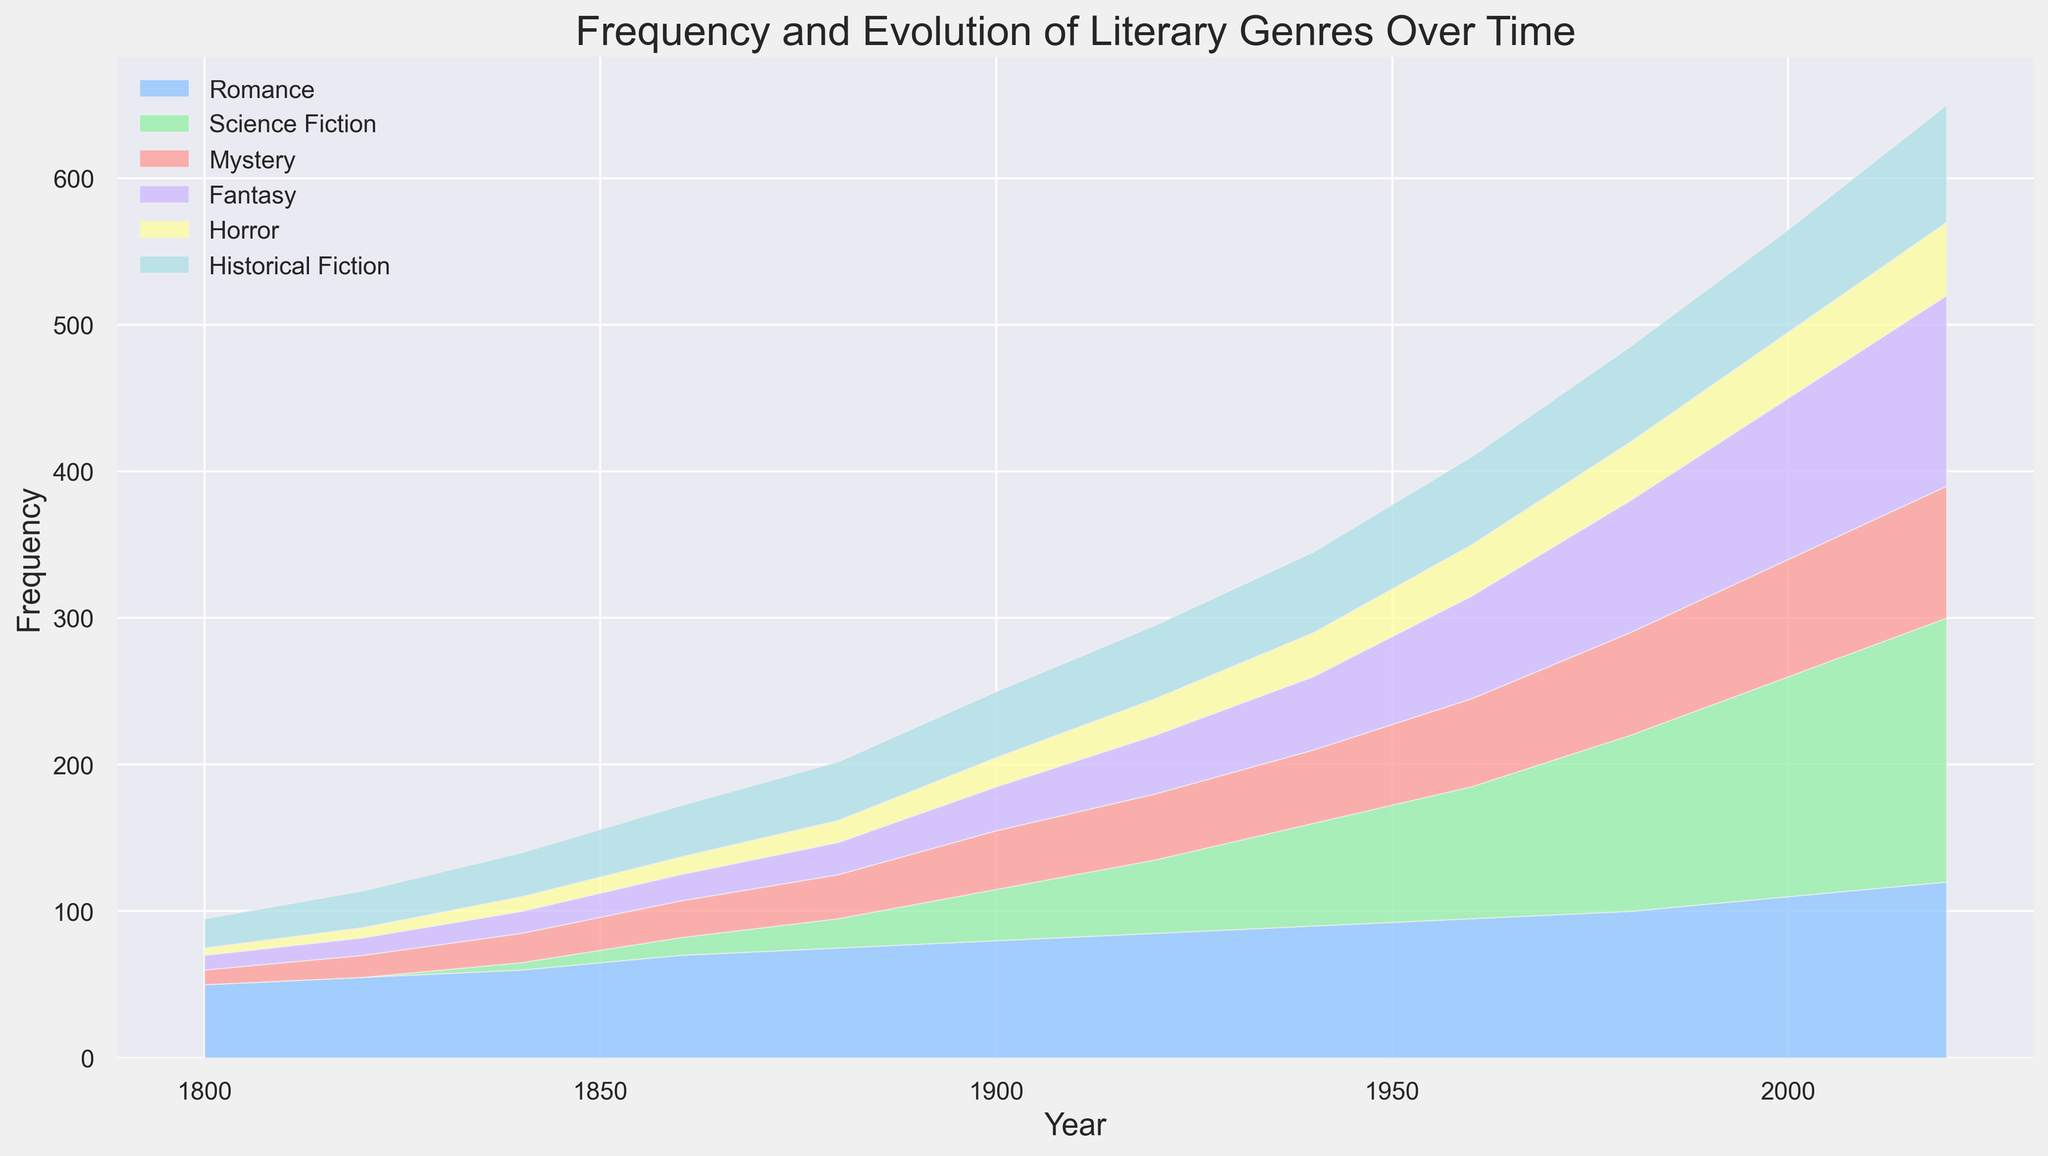What's the most frequently occurring genre in 2020? The most frequently occurring genre in 2020 can be determined by comparing the heights of the stacked areas in 2020. The highest area in 2020 corresponds to the Romance genre.
Answer: Romance Which genre saw its frequency increase the most between 1900 and 2000? To determine this, calculate the difference in frequency for each genre between 1900 and 2000. Romance increased from 80 to 110, Science Fiction from 35 to 150, Mystery from 40 to 80, Fantasy from 30 to 110, Horror from 20 to 45, and Historical Fiction from 45 to 70. Science Fiction had the largest increase (150 - 35 = 115).
Answer: Science Fiction Is the frequency of Horror greater than Romance in 1880? Observe the relative heights of the Horror and Romance areas in 1880. The height for Romance (75) is greater than that for Horror (15).
Answer: No What is the sum of the frequencies of Science Fiction and Fantasy in 1960? Adding the frequency of Science Fiction (90) and Fantasy (70) in 1960 gives 90 + 70 = 160.
Answer: 160 Which two genres' frequencies are equal in 2000? By examining the chart, we can see the stacked areas in 2000 for Romance, Science Fiction, Mystery, Fantasy, Horror, and Historical Fiction. Mystery and Fantasy both have a frequency of 110.
Answer: Mystery and Fantasy How does the frequency of Historical Fiction change from 1840 to 1940? The frequency of Historical Fiction in 1840 is 30 and in 1940 it increases to 55. This indicates an increase of 55 - 30 = 25.
Answer: Increases by 25 Is the total frequency of all genres higher in 2020 than in 1900? To find this, sum the frequencies of all genres in 2020 and 1900. In 2020: 120 (Romance) + 180 (Science Fiction) + 90 (Mystery) + 130 (Fantasy) + 50 (Horror) + 80 (Historical Fiction) = 650. In 1900: 80 + 35 + 40 + 30 + 20 + 45 = 250. Since 650 > 250, the total is higher in 2020.
Answer: Yes What genre has the lowest frequency in 1920 and what is it? The smallest height in 1920 is observed for Historical Fiction with a frequency of 50.
Answer: Historical Fiction, 50 Which genre experienced the most consistent increase over time? By visually inspecting the chart, Romance shows a steady and consistent increase in frequency from 1800 to 2020, without any dips.
Answer: Romance Compare the frequency of Fantasy and Horror in the year 1980. Which is higher? By observing the areas for Fantasy and Horror in 1980, Fantasy has a frequency of 90 and Horror has a frequency of 40. Thus, Fantasy is higher.
Answer: Fantasy 